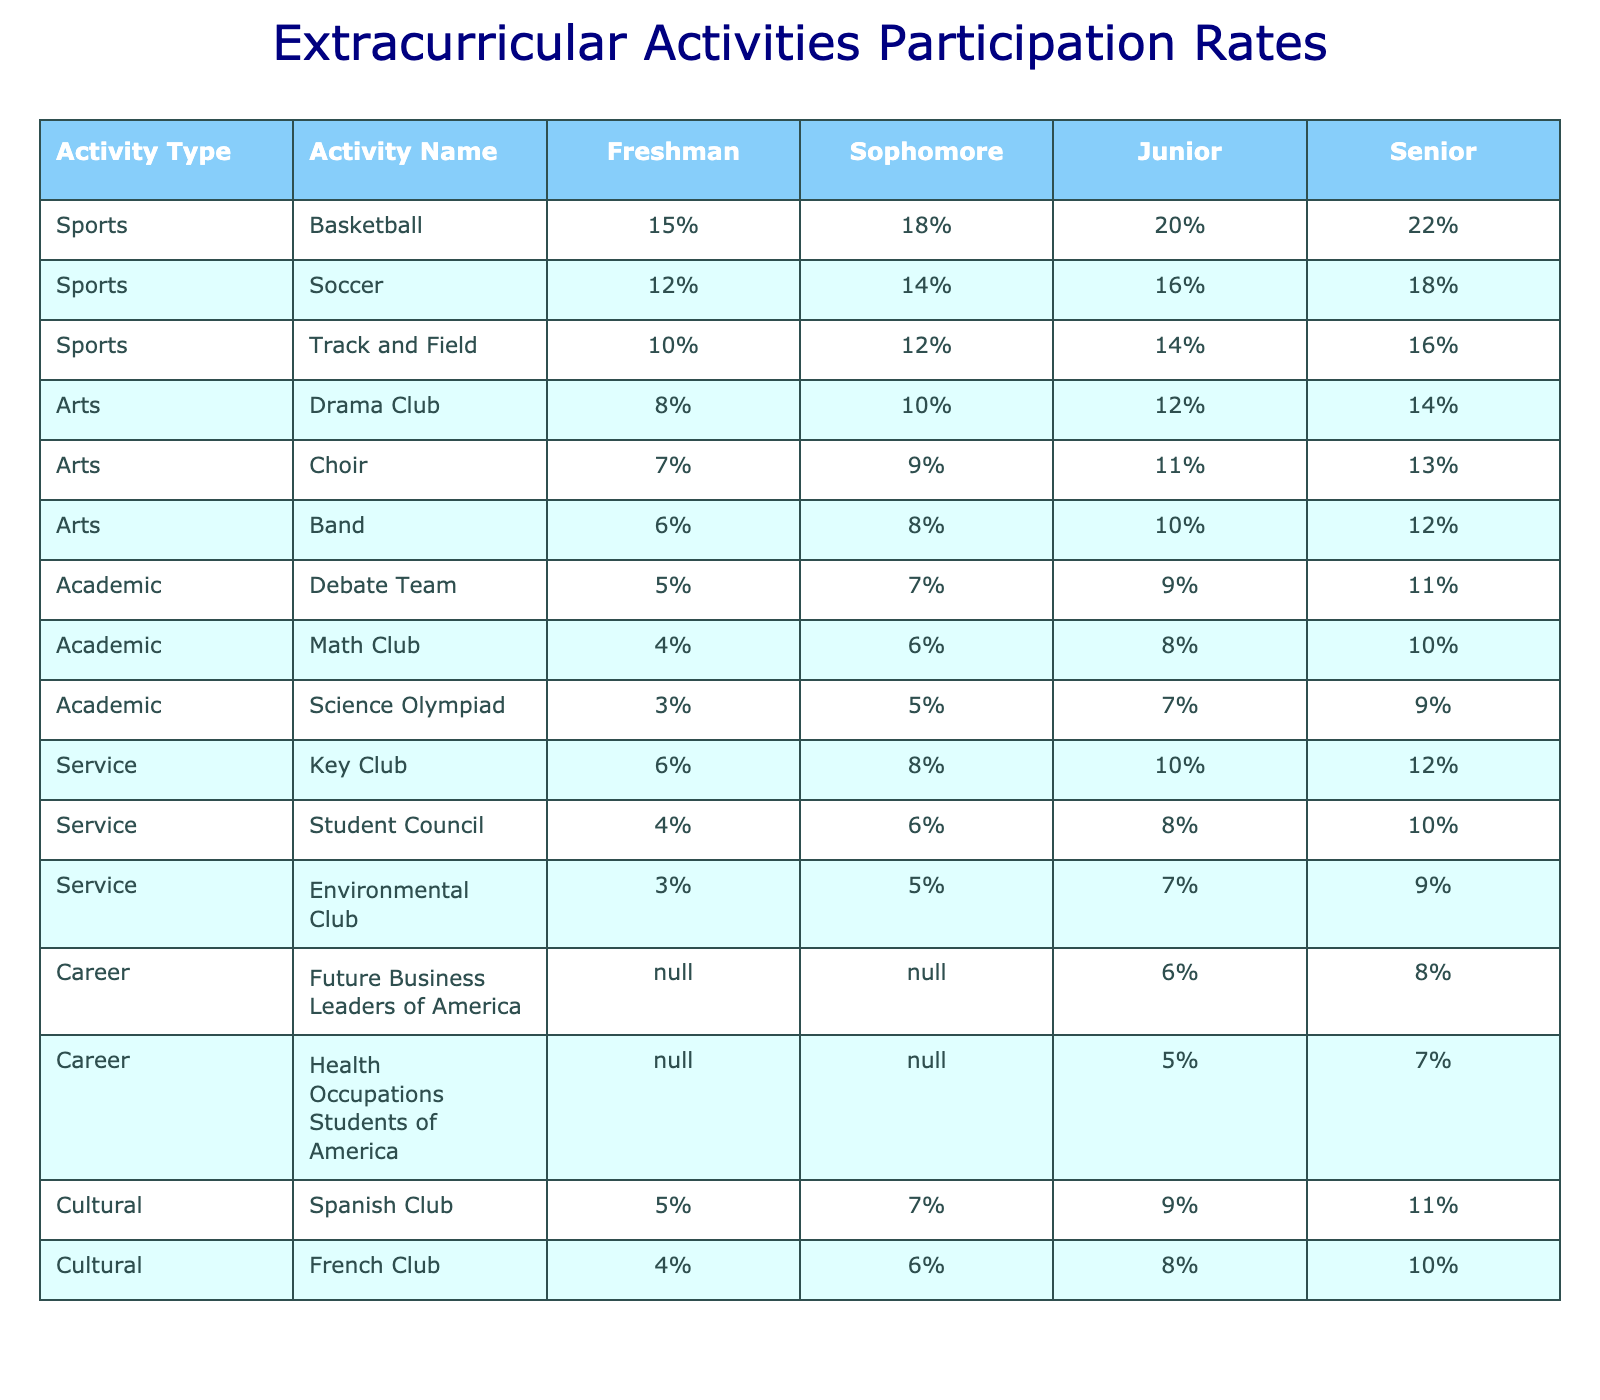What is the participation rate for Drama Club among seniors? The table shows that the participation rate for Drama Club for seniors is 14%.
Answer: 14% Which activity has the highest participation rate among juniors? Looking at the table, Track and Field has the highest participation rate among juniors at 14%.
Answer: Track and Field What is the average participation rate for basketball across all grade levels? We add up the participation rates: (15 + 18 + 20 + 22) / 4 = 75 / 4 = 18.75%.
Answer: 18.75% Is the participation rate for Science Olympiad higher among seniors than among freshmen? The participation rate for seniors is 9%, while for freshmen, it is 3%. Since 9% is greater than 3%, the answer is yes.
Answer: Yes What is the total participation rate for all sports among sophomores? The participation rates for sports among sophomores are: Basketball (18%), Soccer (14%), and Track and Field (12%). Summing these gives 18 + 14 + 12 = 44%.
Answer: 44% Which service activity has the lowest participation rate among freshmen? The table lists Environmental Club, which has a participation rate of 3% among freshmen, the lowest among service activities.
Answer: Environmental Club For seniors, what is the difference in participation rates between Soccer and Choir? The participation rate for Soccer among seniors is 18%, while for Choir, it is 13%. The difference is 18 - 13 = 5%.
Answer: 5% What is the total participation rate for cultural activities among juniors? The cultural activities for juniors are Spanish Club (9%) and French Club (8%). Adding these gives 9 + 8 = 17%.
Answer: 17% Are there any activities with no participation rates for freshmen? The table lists Future Business Leaders of America and Health Occupations Students of America, which show "N/A" for freshmen, indicating no participation rates.
Answer: Yes Which academic activity shows the least growth in participation from freshmen to seniors? Debate Team shows participation rates of 5% for freshmen and 11% for seniors. The growth is 11 - 5 = 6%. This is the least growth compared to others.
Answer: Debate Team 